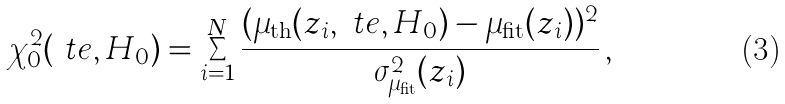<formula> <loc_0><loc_0><loc_500><loc_500>\chi ^ { 2 } _ { 0 } ( \ t e , H _ { 0 } ) = \sum _ { i = 1 } ^ { N } \frac { ( \mu _ { \text {th} } ( z _ { i } , \ t e , H _ { 0 } ) - \mu _ { \text {fit} } ( z _ { i } ) ) ^ { 2 } } { \sigma ^ { 2 } _ { \mu _ { \text {fit} } } ( z _ { i } ) } \, ,</formula> 